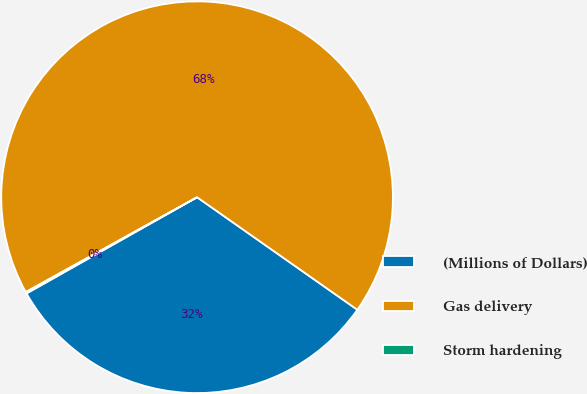Convert chart. <chart><loc_0><loc_0><loc_500><loc_500><pie_chart><fcel>(Millions of Dollars)<fcel>Gas delivery<fcel>Storm hardening<nl><fcel>32.08%<fcel>67.79%<fcel>0.13%<nl></chart> 